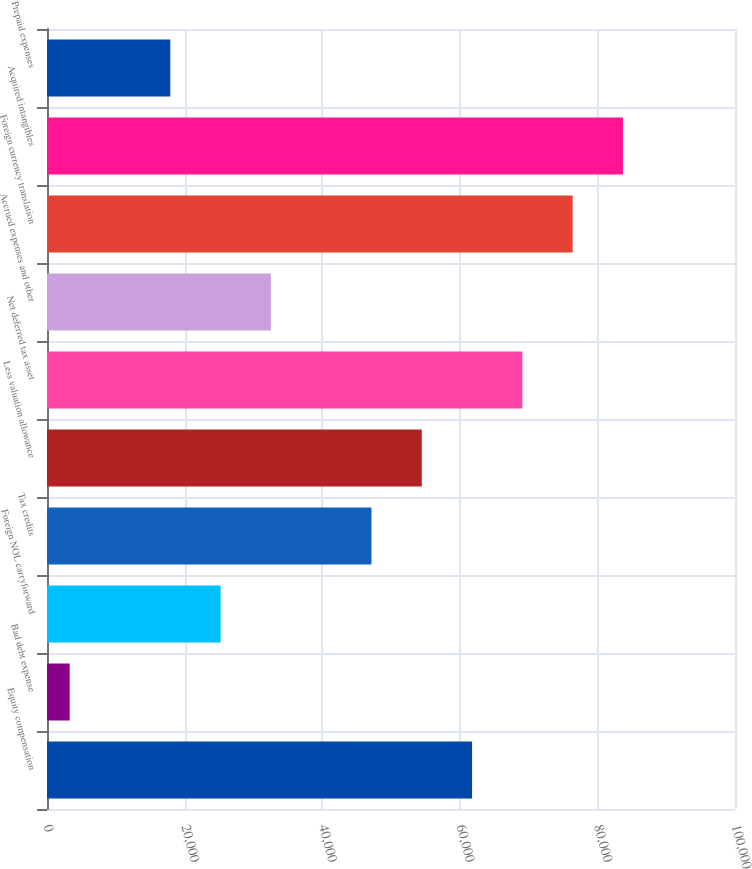Convert chart. <chart><loc_0><loc_0><loc_500><loc_500><bar_chart><fcel>Equity compensation<fcel>Bad debt expense<fcel>Foreign NOL carryforward<fcel>Tax credits<fcel>Less valuation allowance<fcel>Net deferred tax asset<fcel>Accrued expenses and other<fcel>Foreign currency translation<fcel>Acquired intangibles<fcel>Prepaid expenses<nl><fcel>61783.6<fcel>3298<fcel>25230.1<fcel>47162.2<fcel>54472.9<fcel>69094.3<fcel>32540.8<fcel>76405<fcel>83715.7<fcel>17919.4<nl></chart> 